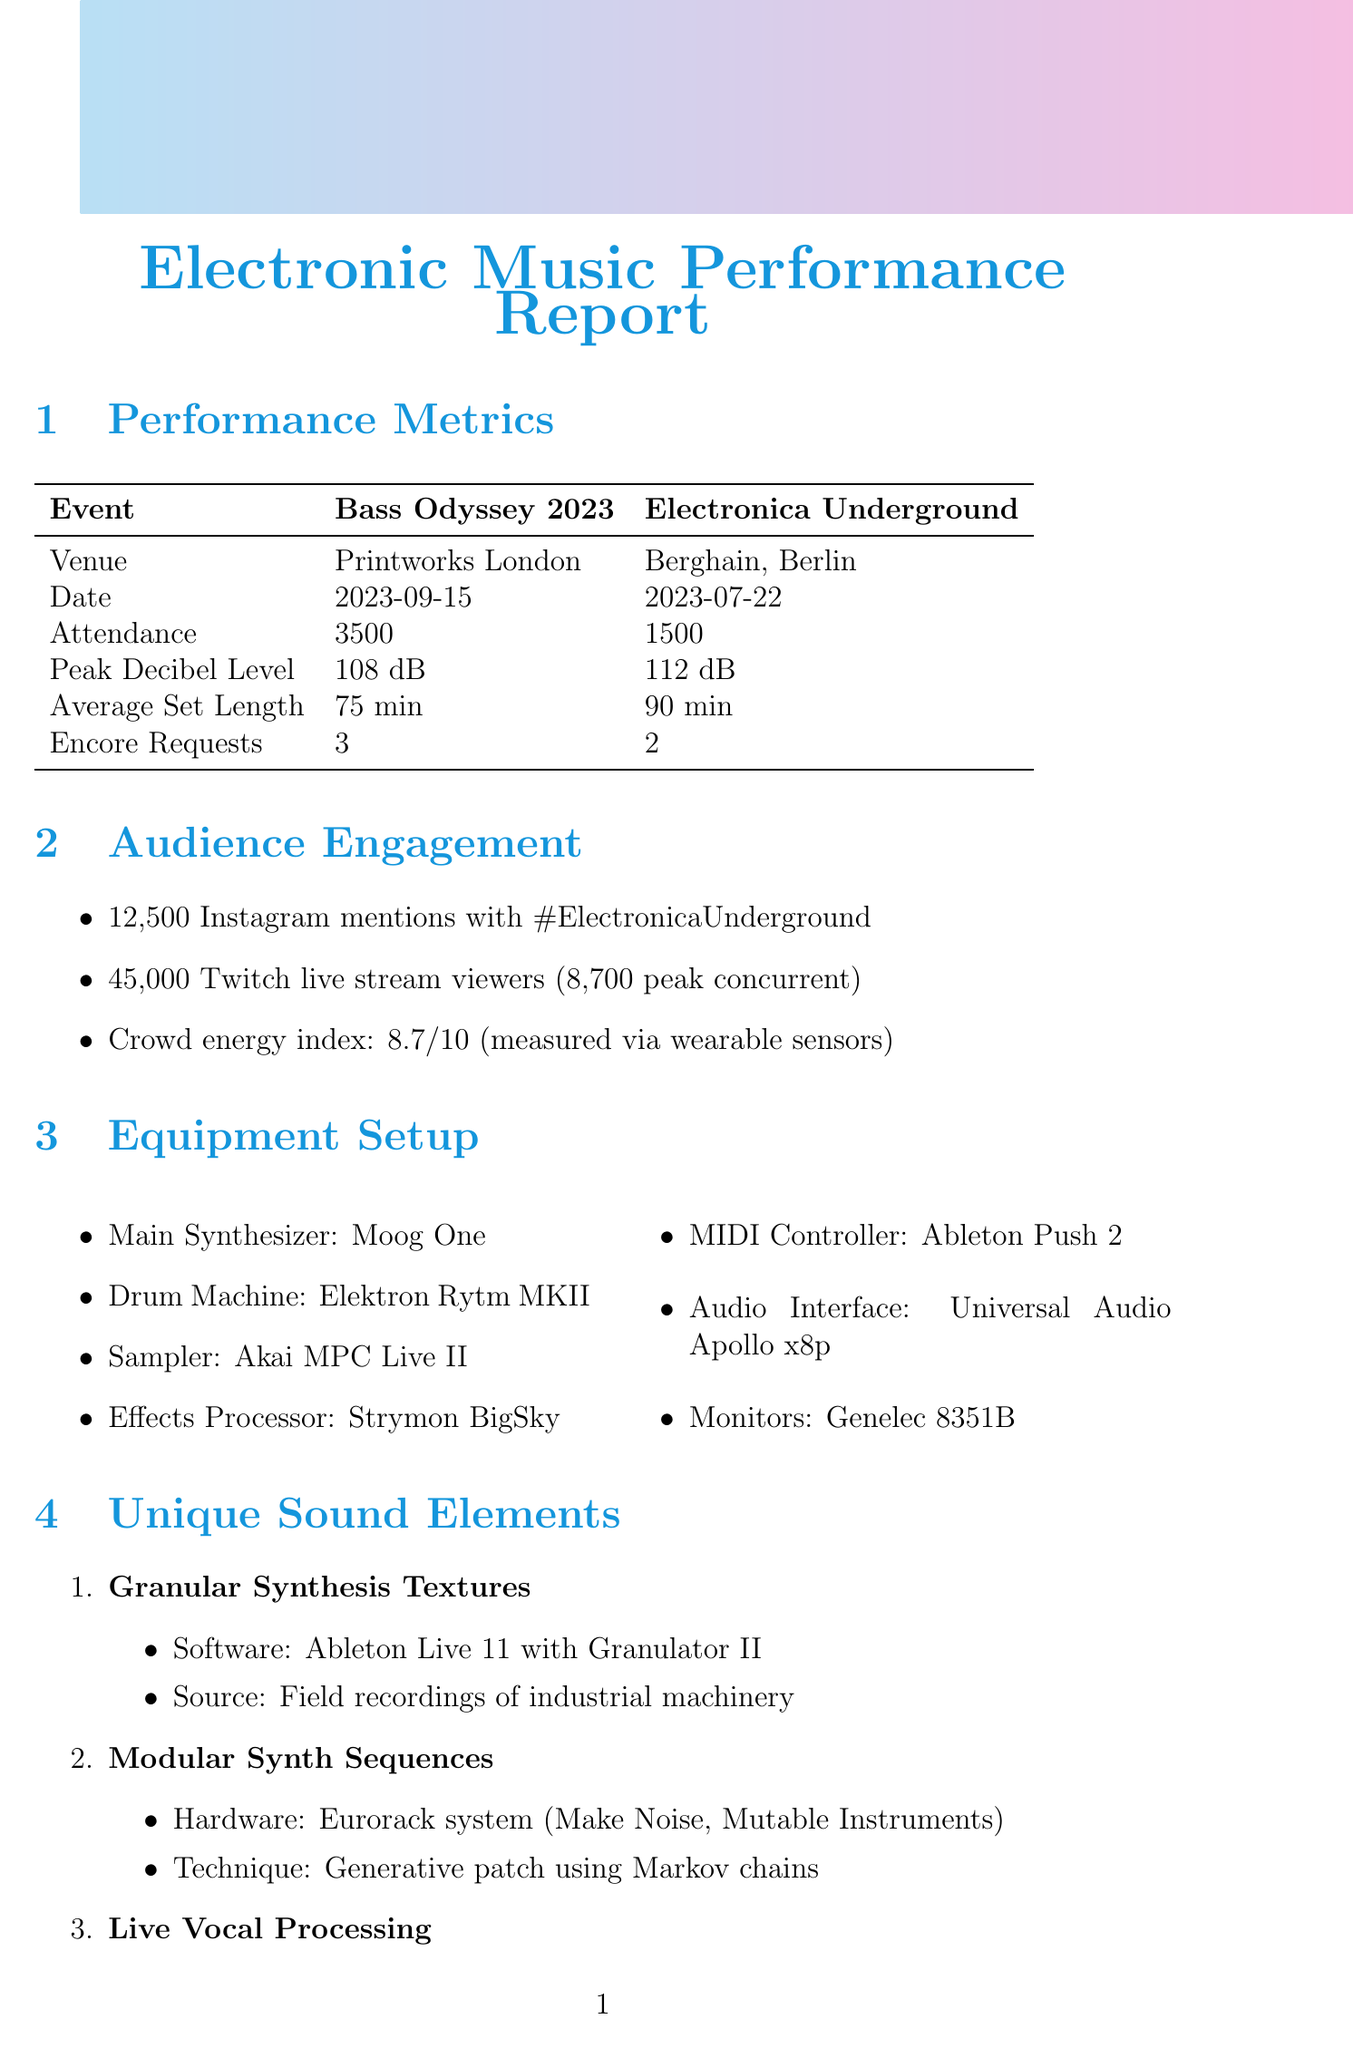What was the attendance at Bass Odyssey 2023? The attendance is mentioned in the performance metrics section for the event Bass Odyssey 2023 as 3500.
Answer: 3500 What is the peak decibel level for Electronica Underground? The peak decibel level is found in the performance metrics section under the event Electronica Underground, which is 112 dB.
Answer: 112 dB How many Instagram mentions were there for Electronica Underground? The number of mentions on Instagram is provided in the audience engagement data as 12,500 with the hashtag #ElectronicaUnderground.
Answer: 12500 What is the crowd energy index value? The crowd energy index is stated in the audience engagement section as 8.7 out of 10, derived from wearable sensor data.
Answer: 8.7 What age range does the audience demographic fall within? The age range is specified in the audience demographics section, which states it is from 18 to 35.
Answer: 18-35 Which main synthesizer was used in the equipment setup? The main synthesizer is listed as Moog One in the equipment setup section of the document.
Answer: Moog One What type of music preference was identified for the audience? The music preference is detailed in the audience demographics section as experimental electronic, IDM, ambient.
Answer: Experimental electronic, IDM, ambient What was a key element of the track Quantum Flux? One of the key elements specified for the track Quantum Flux is live sampling of audience cheers, found in the performance highlights.
Answer: Live sampling of audience cheers How long was the performance of Neural Network Nocturne? The duration of the track Neural Network Nocturne is mentioned in the performance highlights section as 12:30.
Answer: 12:30 